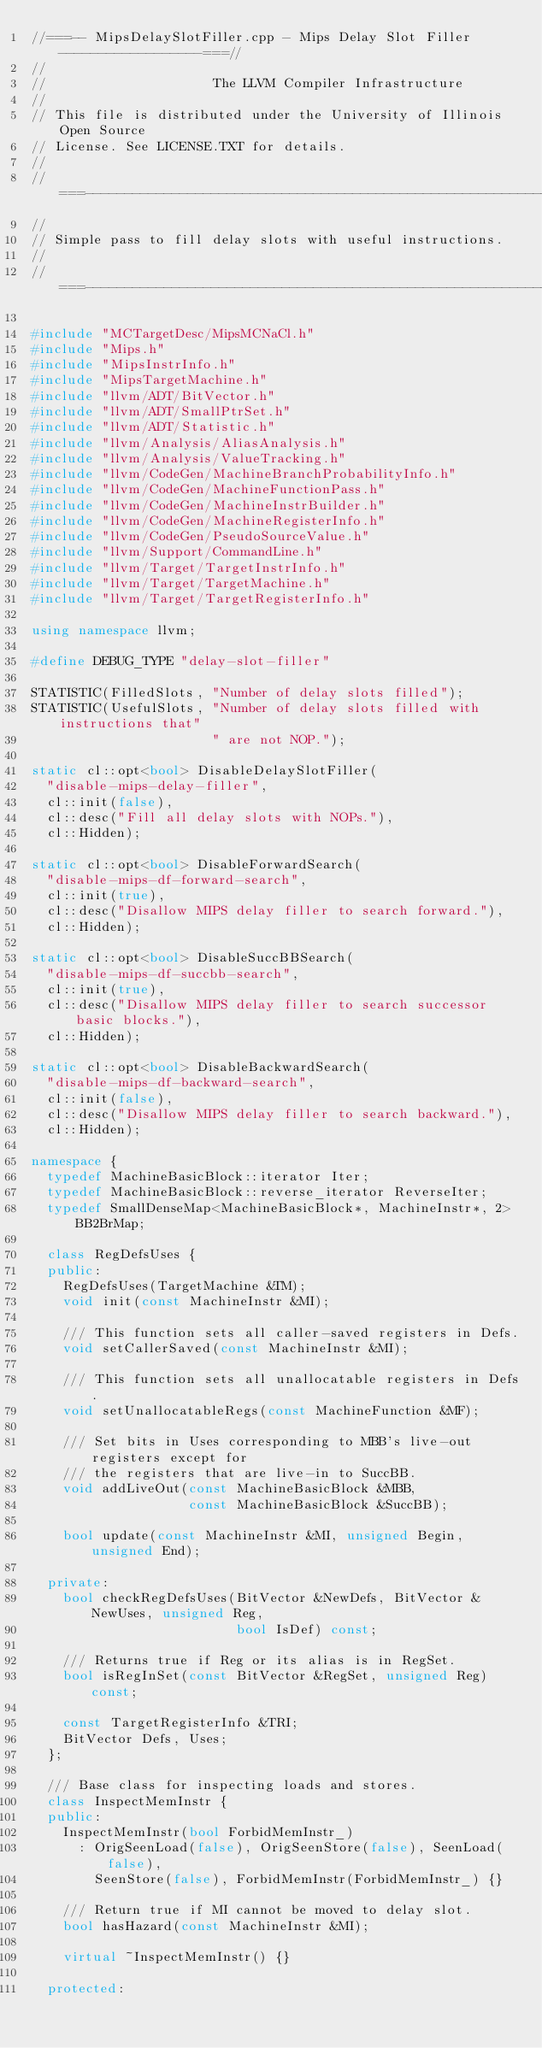<code> <loc_0><loc_0><loc_500><loc_500><_C++_>//===-- MipsDelaySlotFiller.cpp - Mips Delay Slot Filler ------------------===//
//
//                     The LLVM Compiler Infrastructure
//
// This file is distributed under the University of Illinois Open Source
// License. See LICENSE.TXT for details.
//
//===----------------------------------------------------------------------===//
//
// Simple pass to fill delay slots with useful instructions.
//
//===----------------------------------------------------------------------===//

#include "MCTargetDesc/MipsMCNaCl.h"
#include "Mips.h"
#include "MipsInstrInfo.h"
#include "MipsTargetMachine.h"
#include "llvm/ADT/BitVector.h"
#include "llvm/ADT/SmallPtrSet.h"
#include "llvm/ADT/Statistic.h"
#include "llvm/Analysis/AliasAnalysis.h"
#include "llvm/Analysis/ValueTracking.h"
#include "llvm/CodeGen/MachineBranchProbabilityInfo.h"
#include "llvm/CodeGen/MachineFunctionPass.h"
#include "llvm/CodeGen/MachineInstrBuilder.h"
#include "llvm/CodeGen/MachineRegisterInfo.h"
#include "llvm/CodeGen/PseudoSourceValue.h"
#include "llvm/Support/CommandLine.h"
#include "llvm/Target/TargetInstrInfo.h"
#include "llvm/Target/TargetMachine.h"
#include "llvm/Target/TargetRegisterInfo.h"

using namespace llvm;

#define DEBUG_TYPE "delay-slot-filler"

STATISTIC(FilledSlots, "Number of delay slots filled");
STATISTIC(UsefulSlots, "Number of delay slots filled with instructions that"
                       " are not NOP.");

static cl::opt<bool> DisableDelaySlotFiller(
  "disable-mips-delay-filler",
  cl::init(false),
  cl::desc("Fill all delay slots with NOPs."),
  cl::Hidden);

static cl::opt<bool> DisableForwardSearch(
  "disable-mips-df-forward-search",
  cl::init(true),
  cl::desc("Disallow MIPS delay filler to search forward."),
  cl::Hidden);

static cl::opt<bool> DisableSuccBBSearch(
  "disable-mips-df-succbb-search",
  cl::init(true),
  cl::desc("Disallow MIPS delay filler to search successor basic blocks."),
  cl::Hidden);

static cl::opt<bool> DisableBackwardSearch(
  "disable-mips-df-backward-search",
  cl::init(false),
  cl::desc("Disallow MIPS delay filler to search backward."),
  cl::Hidden);

namespace {
  typedef MachineBasicBlock::iterator Iter;
  typedef MachineBasicBlock::reverse_iterator ReverseIter;
  typedef SmallDenseMap<MachineBasicBlock*, MachineInstr*, 2> BB2BrMap;

  class RegDefsUses {
  public:
    RegDefsUses(TargetMachine &TM);
    void init(const MachineInstr &MI);

    /// This function sets all caller-saved registers in Defs.
    void setCallerSaved(const MachineInstr &MI);

    /// This function sets all unallocatable registers in Defs.
    void setUnallocatableRegs(const MachineFunction &MF);

    /// Set bits in Uses corresponding to MBB's live-out registers except for
    /// the registers that are live-in to SuccBB.
    void addLiveOut(const MachineBasicBlock &MBB,
                    const MachineBasicBlock &SuccBB);

    bool update(const MachineInstr &MI, unsigned Begin, unsigned End);

  private:
    bool checkRegDefsUses(BitVector &NewDefs, BitVector &NewUses, unsigned Reg,
                          bool IsDef) const;

    /// Returns true if Reg or its alias is in RegSet.
    bool isRegInSet(const BitVector &RegSet, unsigned Reg) const;

    const TargetRegisterInfo &TRI;
    BitVector Defs, Uses;
  };

  /// Base class for inspecting loads and stores.
  class InspectMemInstr {
  public:
    InspectMemInstr(bool ForbidMemInstr_)
      : OrigSeenLoad(false), OrigSeenStore(false), SeenLoad(false),
        SeenStore(false), ForbidMemInstr(ForbidMemInstr_) {}

    /// Return true if MI cannot be moved to delay slot.
    bool hasHazard(const MachineInstr &MI);

    virtual ~InspectMemInstr() {}

  protected:</code> 